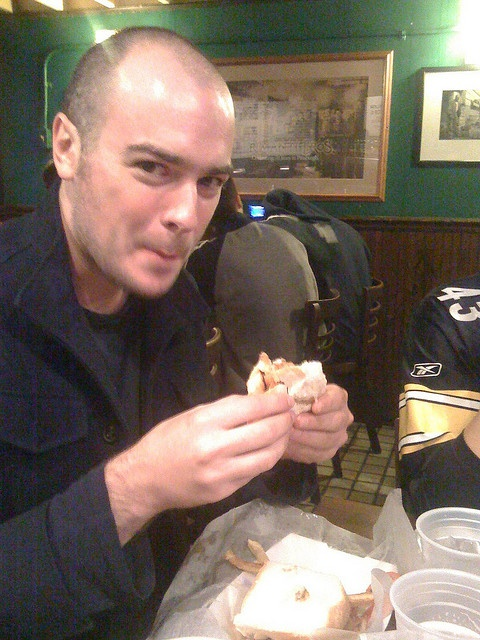Describe the objects in this image and their specific colors. I can see people in khaki, black, lightpink, lightgray, and gray tones, people in khaki, black, and ivory tones, people in khaki, gray, and black tones, sandwich in khaki, white, and tan tones, and people in khaki, black, gray, and darkgreen tones in this image. 